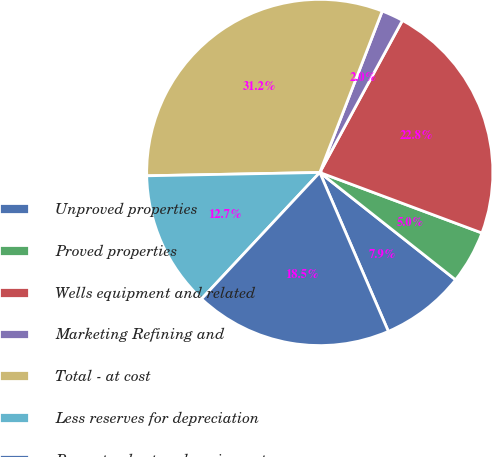Convert chart. <chart><loc_0><loc_0><loc_500><loc_500><pie_chart><fcel>Unproved properties<fcel>Proved properties<fcel>Wells equipment and related<fcel>Marketing Refining and<fcel>Total - at cost<fcel>Less reserves for depreciation<fcel>Property plant and equipment -<nl><fcel>7.87%<fcel>4.96%<fcel>22.76%<fcel>2.05%<fcel>31.18%<fcel>12.73%<fcel>18.45%<nl></chart> 